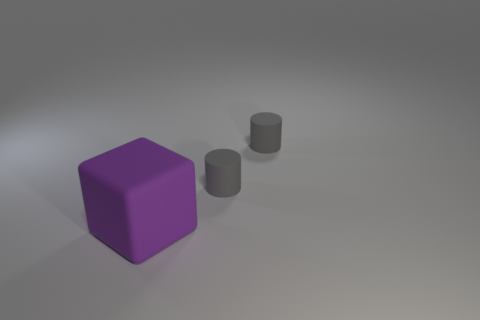Is there any other thing that has the same size as the purple thing?
Offer a terse response. No. Are there any other things that have the same color as the block?
Offer a terse response. No. Are there the same number of purple matte cubes behind the big purple thing and large purple objects?
Provide a succinct answer. No. Is there any other thing that is made of the same material as the block?
Offer a very short reply. Yes. Are there fewer big objects behind the large purple thing than cylinders?
Give a very brief answer. Yes. What number of other things are there of the same shape as the big object?
Your answer should be very brief. 0. What number of things are rubber things behind the cube or objects behind the large object?
Your answer should be compact. 2. What number of objects are big purple things or tiny matte objects?
Your response must be concise. 3. Are there any gray things on the left side of the big cube?
Your response must be concise. No. How many cylinders are either small blue matte things or purple objects?
Make the answer very short. 0. 